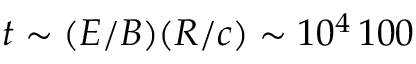Convert formula to latex. <formula><loc_0><loc_0><loc_500><loc_500>t \sim ( E / B ) ( R / c ) \sim 1 0 ^ { 4 } \, 1 0 0</formula> 